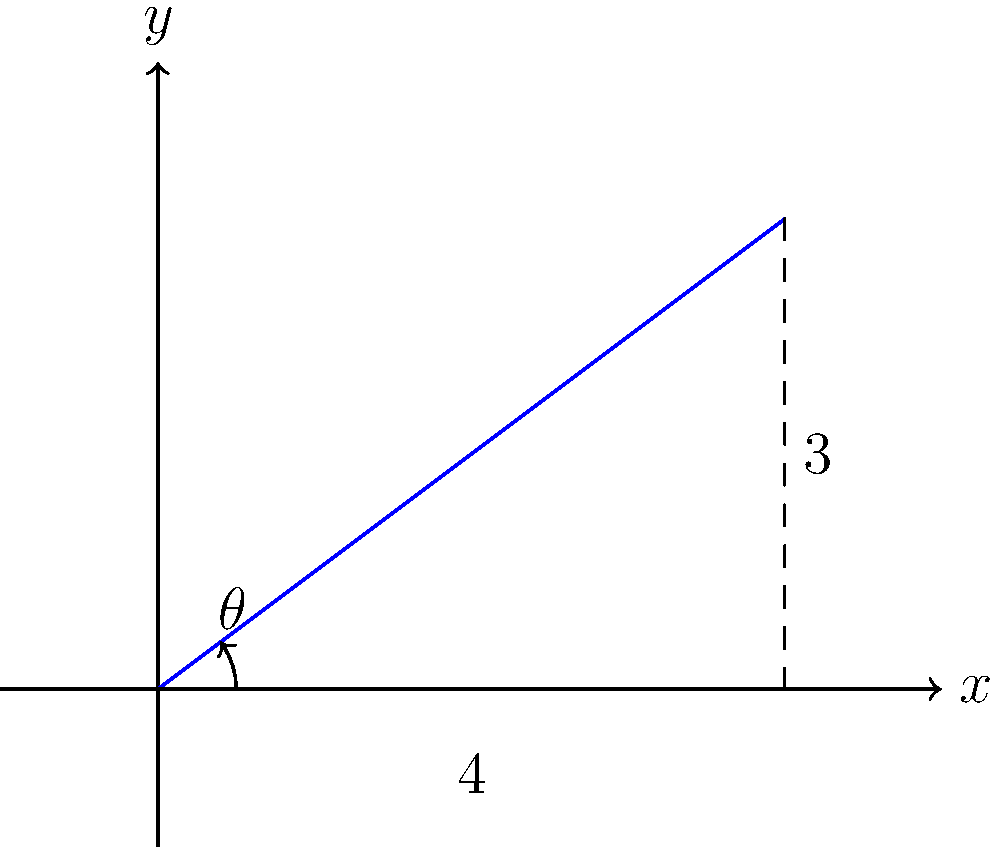In your recording studio, you need to install acoustic panels at a specific angle for optimal sound absorption. The diagram shows the cross-section of a wall and the proposed panel placement. If the panel extends 4 units horizontally and rises 3 units vertically, what is the angle of inclination (θ) for the panel? To find the angle of inclination (θ), we can use the arctangent function, as we have the opposite and adjacent sides of a right triangle formed by the panel and the wall.

Step 1: Identify the sides of the right triangle
- Opposite side (rise) = 3 units
- Adjacent side (run) = 4 units

Step 2: Use the arctangent function to calculate the angle
$\theta = \tan^{-1}(\frac{\text{opposite}}{\text{adjacent}})$

Step 3: Plug in the values
$\theta = \tan^{-1}(\frac{3}{4})$

Step 4: Calculate the result
$\theta \approx 36.87°$

Step 5: Round to the nearest degree
$\theta \approx 37°$

The angle of inclination for the acoustic panel should be approximately 37 degrees for optimal placement in your recording studio.
Answer: $37°$ 